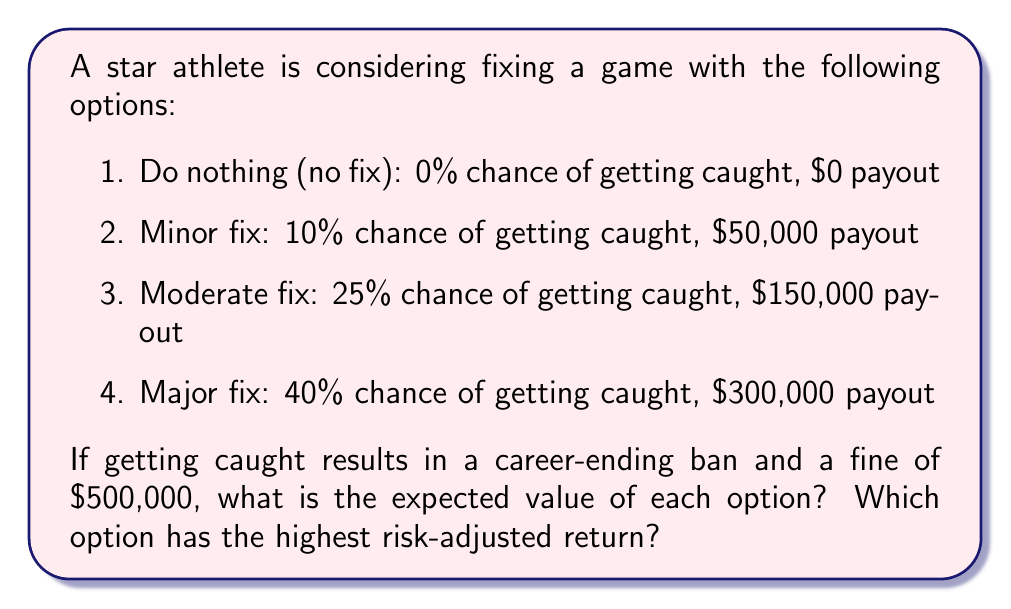What is the answer to this math problem? To solve this problem, we need to calculate the expected value (EV) for each option. The expected value is calculated by multiplying the probability of each outcome by its corresponding value and summing the results.

Let's calculate the EV for each option:

1. Do nothing:
   EV = 100% × $0 = $0

2. Minor fix:
   EV = (90% × $50,000) + (10% × (-$500,000))
      = $45,000 - $50,000
      = -$5,000

3. Moderate fix:
   EV = (75% × $150,000) + (25% × (-$500,000))
      = $112,500 - $125,000
      = -$12,500

4. Major fix:
   EV = (60% × $300,000) + (40% × (-$500,000))
      = $180,000 - $200,000
      = -$20,000

To find the risk-adjusted return, we can use the Sharpe ratio, which is calculated as:

$$ \text{Sharpe Ratio} = \frac{\text{Expected Return} - \text{Risk-free Rate}}{\text{Standard Deviation of Returns}} $$

In this case, we'll use the "do nothing" option as our risk-free rate (0% return). We don't have enough information to calculate the standard deviation, so we'll use the probability of getting caught as a proxy for risk.

Risk-adjusted returns:

1. Do nothing: 0 (by definition)
2. Minor fix: $\frac{-5,000 - 0}{0.10} = -50,000$
3. Moderate fix: $\frac{-12,500 - 0}{0.25} = -50,000$
4. Major fix: $\frac{-20,000 - 0}{0.40} = -50,000$
Answer: The expected values for each option are:
1. Do nothing: $0
2. Minor fix: -$5,000
3. Moderate fix: -$12,500
4. Major fix: -$20,000

The option with the highest expected value is to do nothing ($0).

All fixing options have the same risk-adjusted return of -50,000, which is worse than doing nothing. Therefore, the option with the highest risk-adjusted return is to do nothing (0). 